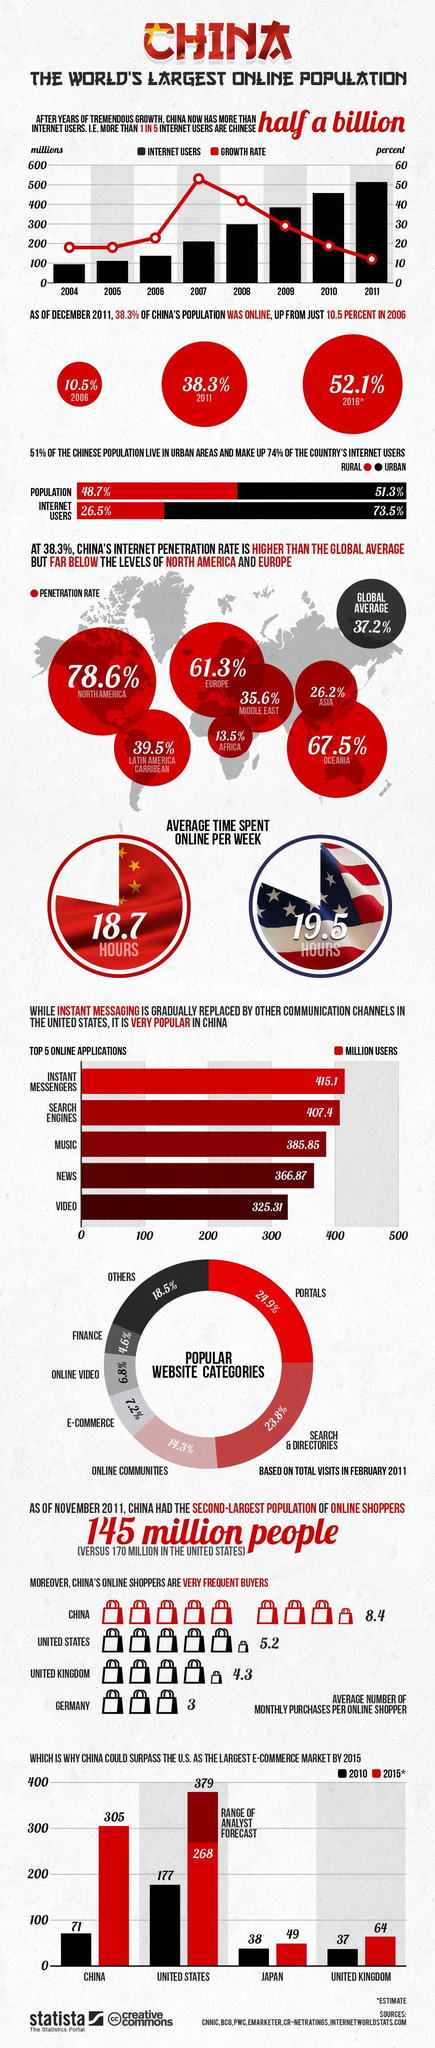Indicate a few pertinent items in this graphic. There are approximately 415.1 million users of instant messenger applications in China. The country with more frequent online purchasers is not known. According to the bar chart, the estimated e-commerce market of China in 2015 was estimated to be 305 billion yuan. According to the bar chart, the e-commerce market of the United States in 2010 was 177 billion U.S. dollars. According to the bar chart, the e-commerce market in Japan in 2010 was approximately 38%. 